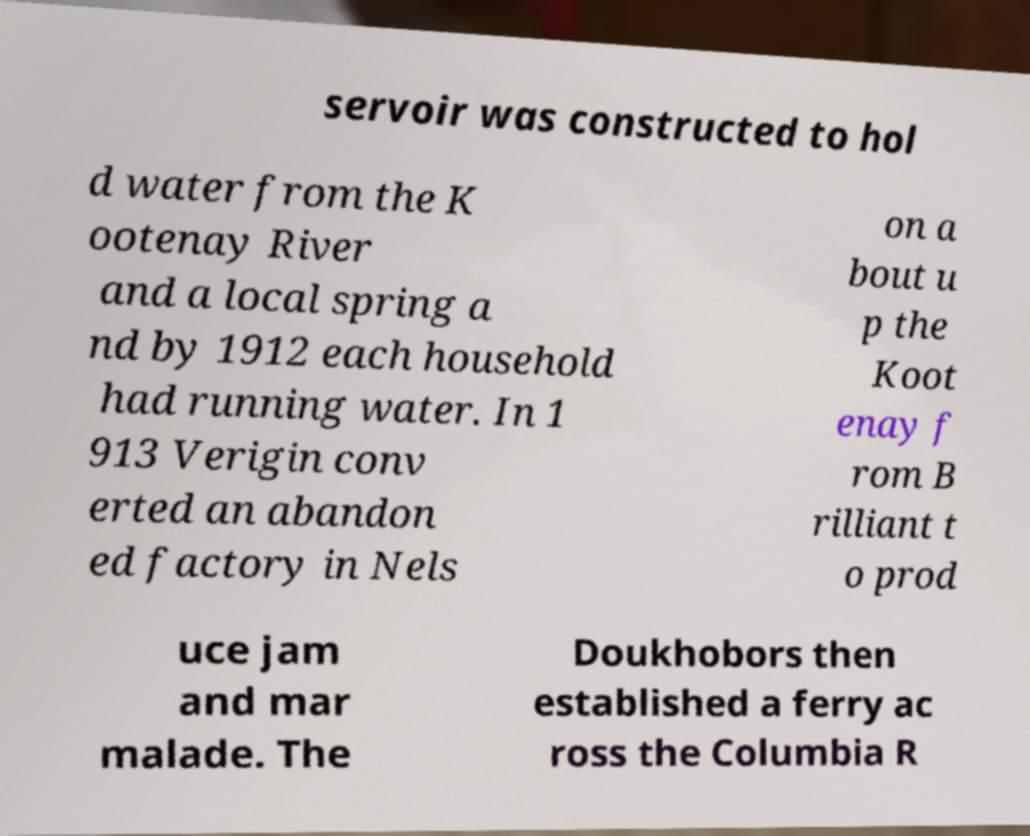Could you assist in decoding the text presented in this image and type it out clearly? servoir was constructed to hol d water from the K ootenay River and a local spring a nd by 1912 each household had running water. In 1 913 Verigin conv erted an abandon ed factory in Nels on a bout u p the Koot enay f rom B rilliant t o prod uce jam and mar malade. The Doukhobors then established a ferry ac ross the Columbia R 